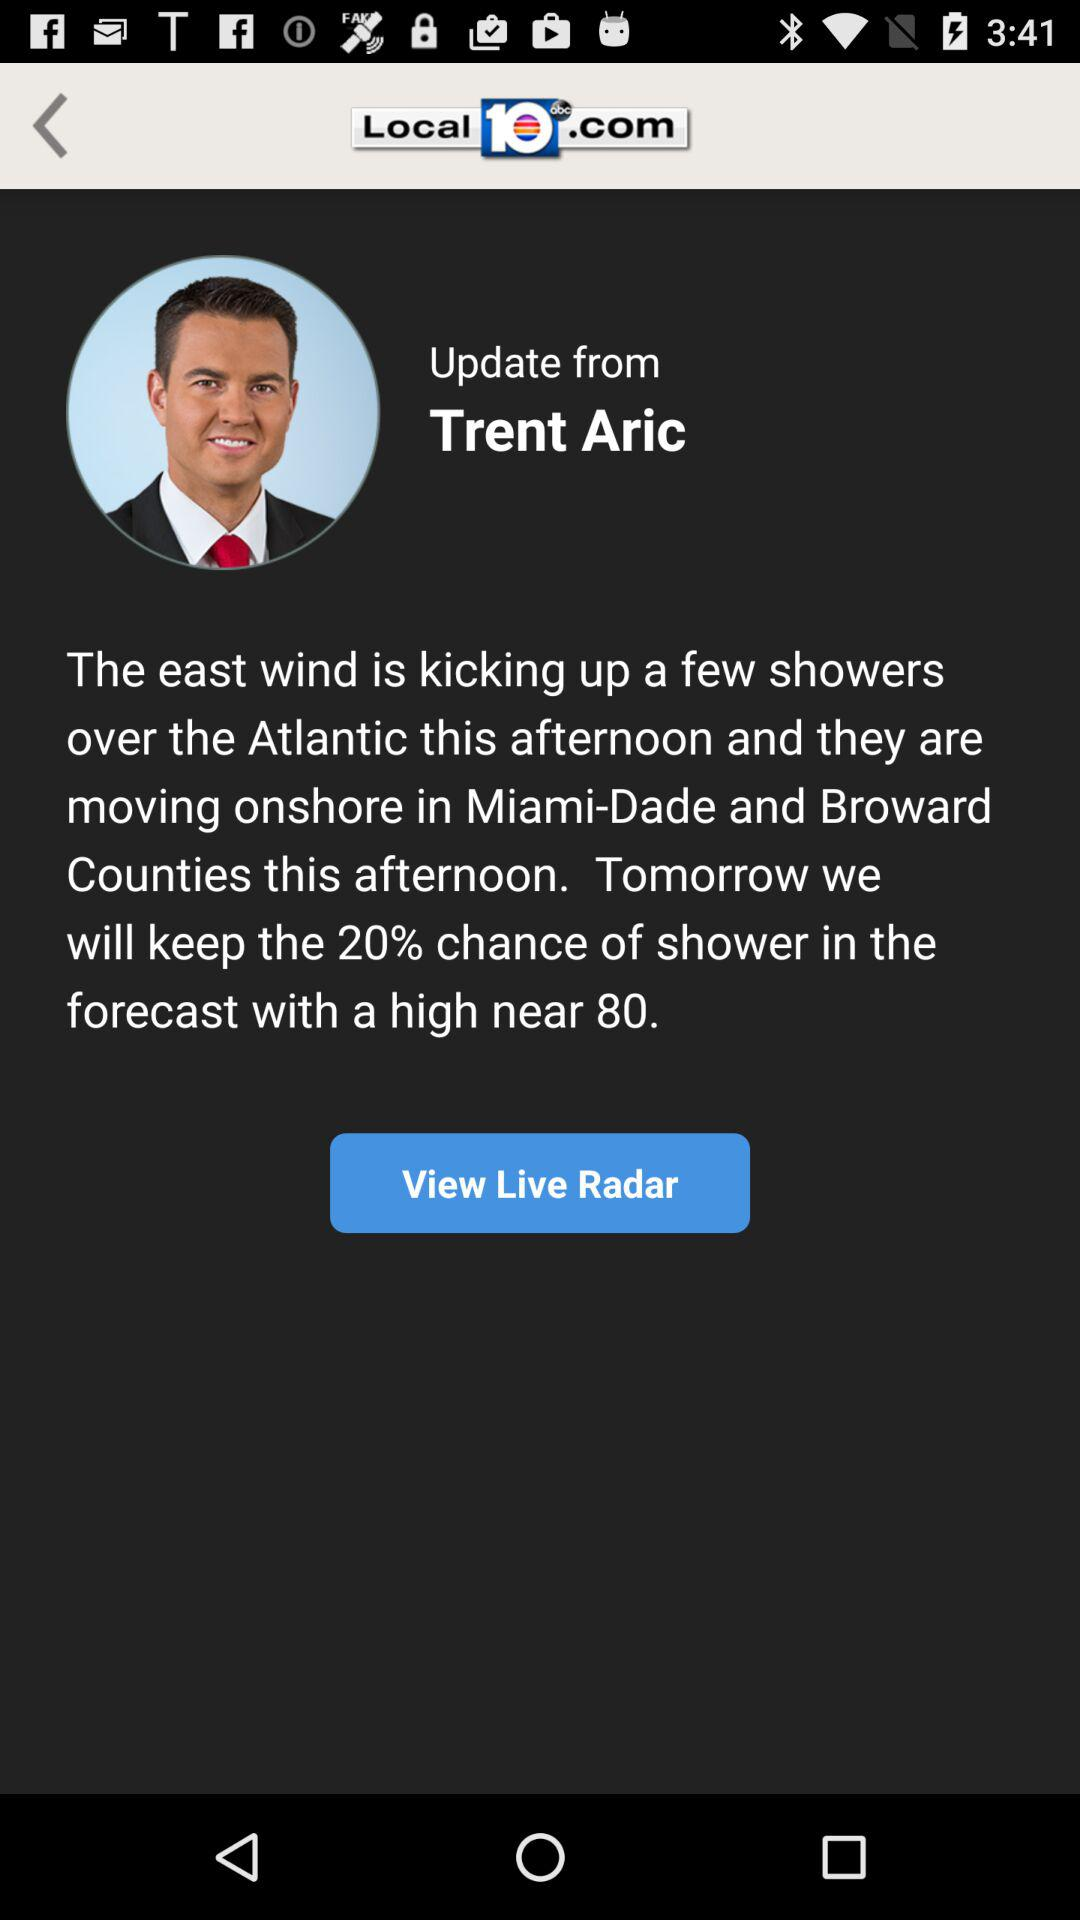What is the percentage chance of a shower tomorrow? The chance of a shower is 20%. 